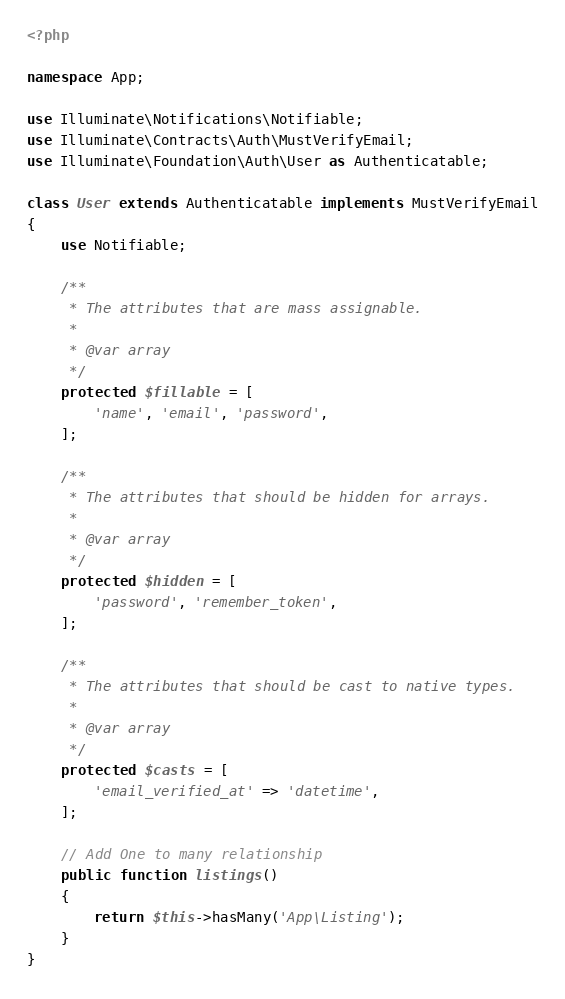<code> <loc_0><loc_0><loc_500><loc_500><_PHP_><?php

namespace App;

use Illuminate\Notifications\Notifiable;
use Illuminate\Contracts\Auth\MustVerifyEmail;
use Illuminate\Foundation\Auth\User as Authenticatable;

class User extends Authenticatable implements MustVerifyEmail
{
    use Notifiable;

    /**
     * The attributes that are mass assignable.
     *
     * @var array
     */
    protected $fillable = [
        'name', 'email', 'password',
    ];

    /**
     * The attributes that should be hidden for arrays.
     *
     * @var array
     */
    protected $hidden = [
        'password', 'remember_token',
    ];

    /**
     * The attributes that should be cast to native types.
     *
     * @var array
     */
    protected $casts = [
        'email_verified_at' => 'datetime',
    ];

    // Add One to many relationship
    public function listings()
    {
        return $this->hasMany('App\Listing');
    }
}
</code> 